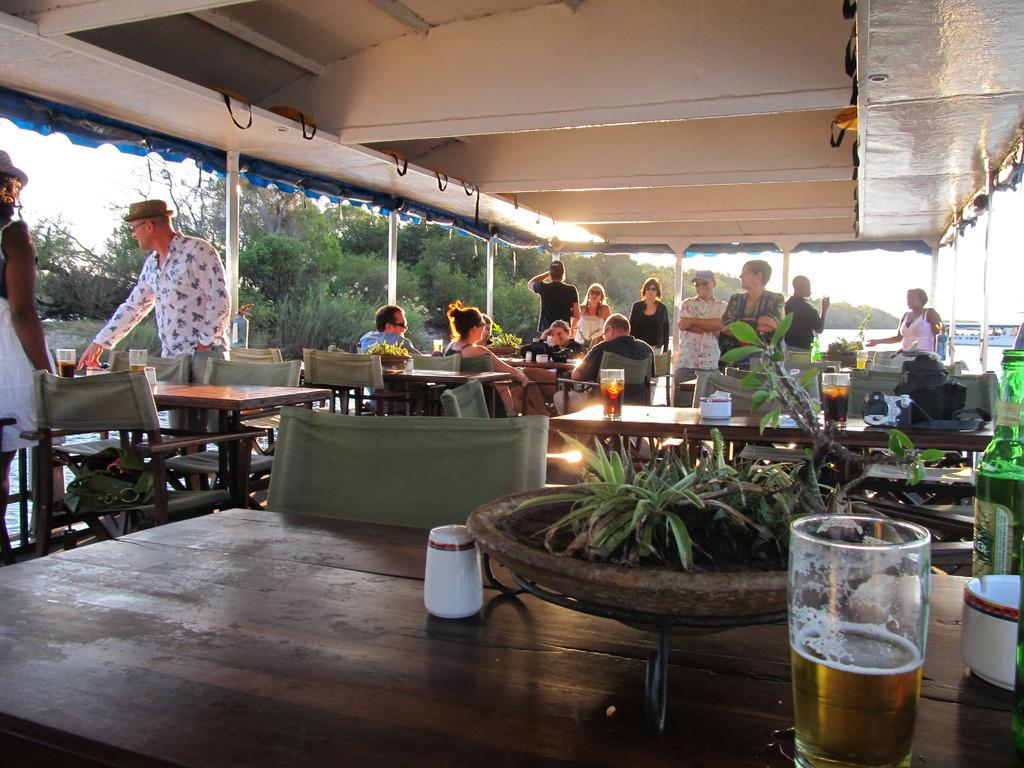Where was the image taken? The image was taken outdoors. How many people are standing on the left side of the image? There are two people standing on the left side of the image. What are the people in the image doing? There are people sitting around tables in the image. What can be seen in the background of the image? Trees and the sky are visible in the background of the image. Can you see a rabbit wearing a cap in the image? No, there is no rabbit or cap present in the image. 